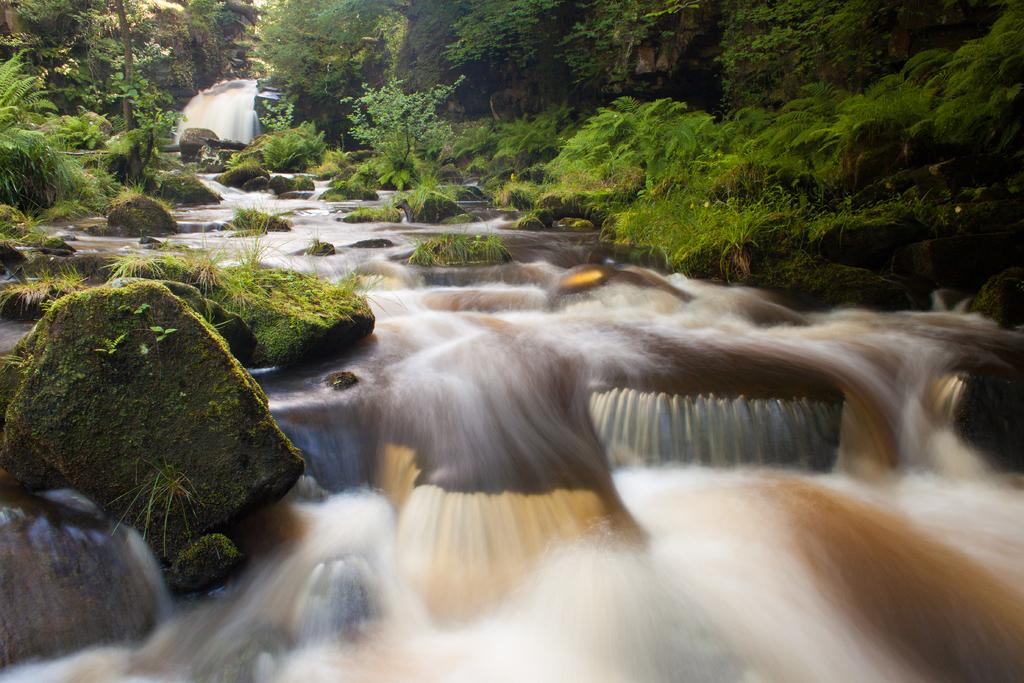What natural feature is the main subject of the image? There is a waterfall in the image. What else can be seen in the image besides the waterfall? There are rocks and trees in the image. What is present at the bottom of the waterfall? There is water at the bottom of the waterfall. What type of airport can be seen near the waterfall in the image? There is no airport present in the image; it features a waterfall, rocks, and trees. What is the purpose of the waterfall in the image? The purpose of the waterfall cannot be determined from the image alone, as it is a natural feature. 